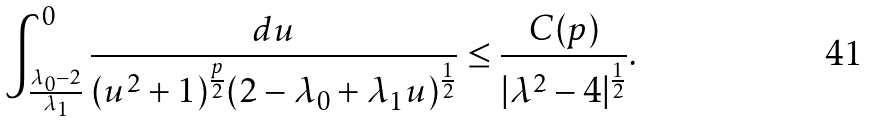<formula> <loc_0><loc_0><loc_500><loc_500>\int _ { \frac { \lambda _ { 0 } - 2 } { \lambda _ { 1 } } } ^ { 0 } \frac { d u } { ( u ^ { 2 } + 1 ) ^ { \frac { p } { 2 } } ( 2 - \lambda _ { 0 } + \lambda _ { 1 } u ) ^ { \frac { 1 } { 2 } } } \leq \frac { C ( p ) } { | \lambda ^ { 2 } - 4 | ^ { \frac { 1 } { 2 } } } .</formula> 